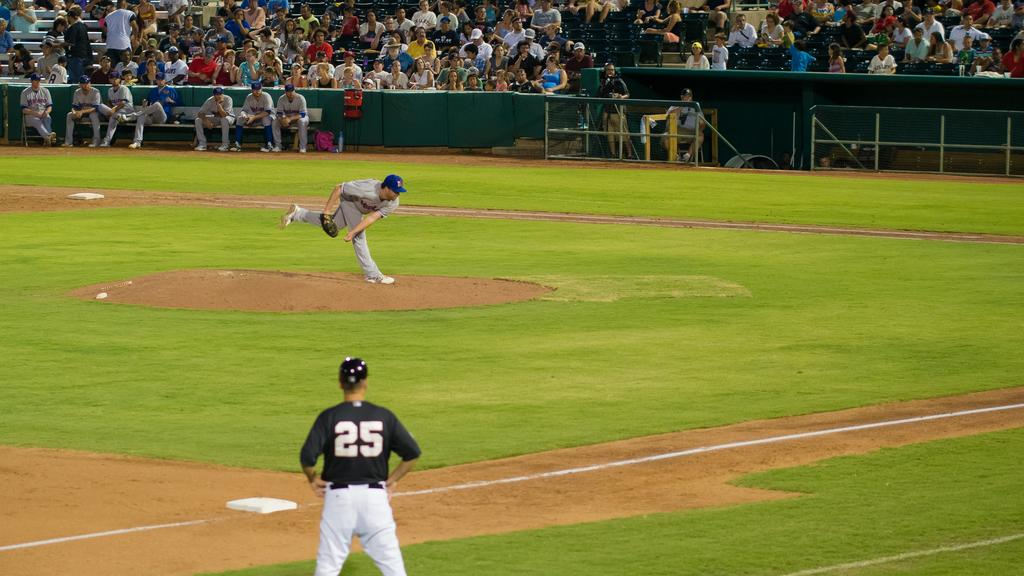<image>
Share a concise interpretation of the image provided. A pitcher finishes his pitch as the opposing player on the third base wearing no. 25 looks on. 